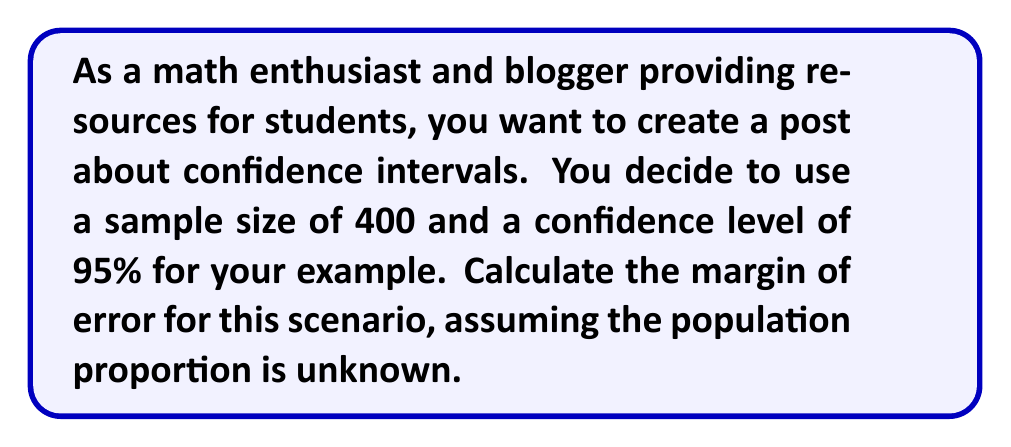Could you help me with this problem? Let's approach this step-by-step:

1) The formula for the margin of error (ME) is:

   $$ ME = z_{\frac{\alpha}{2}} \sqrt{\frac{p(1-p)}{n}} $$

   Where:
   - $z_{\frac{\alpha}{2}}$ is the critical value from the standard normal distribution
   - $p$ is the sample proportion
   - $n$ is the sample size

2) For a 95% confidence level, $\alpha = 1 - 0.95 = 0.05$
   The critical value $z_{\frac{\alpha}{2}} = z_{0.025} = 1.96$

3) Since the population proportion is unknown, we use the most conservative estimate of $p = 0.5$, which gives the largest possible margin of error.

4) We're given that the sample size $n = 400$

5) Now, let's substitute these values into our formula:

   $$ ME = 1.96 \sqrt{\frac{0.5(1-0.5)}{400}} $$

6) Simplify inside the square root:

   $$ ME = 1.96 \sqrt{\frac{0.25}{400}} $$

7) Calculate:

   $$ ME = 1.96 \sqrt{0.000625} = 1.96 * 0.025 = 0.049 $$

8) The margin of error is typically expressed as a percentage, so we multiply by 100:

   $$ ME = 0.049 * 100 = 4.9\% $$
Answer: 4.9% 